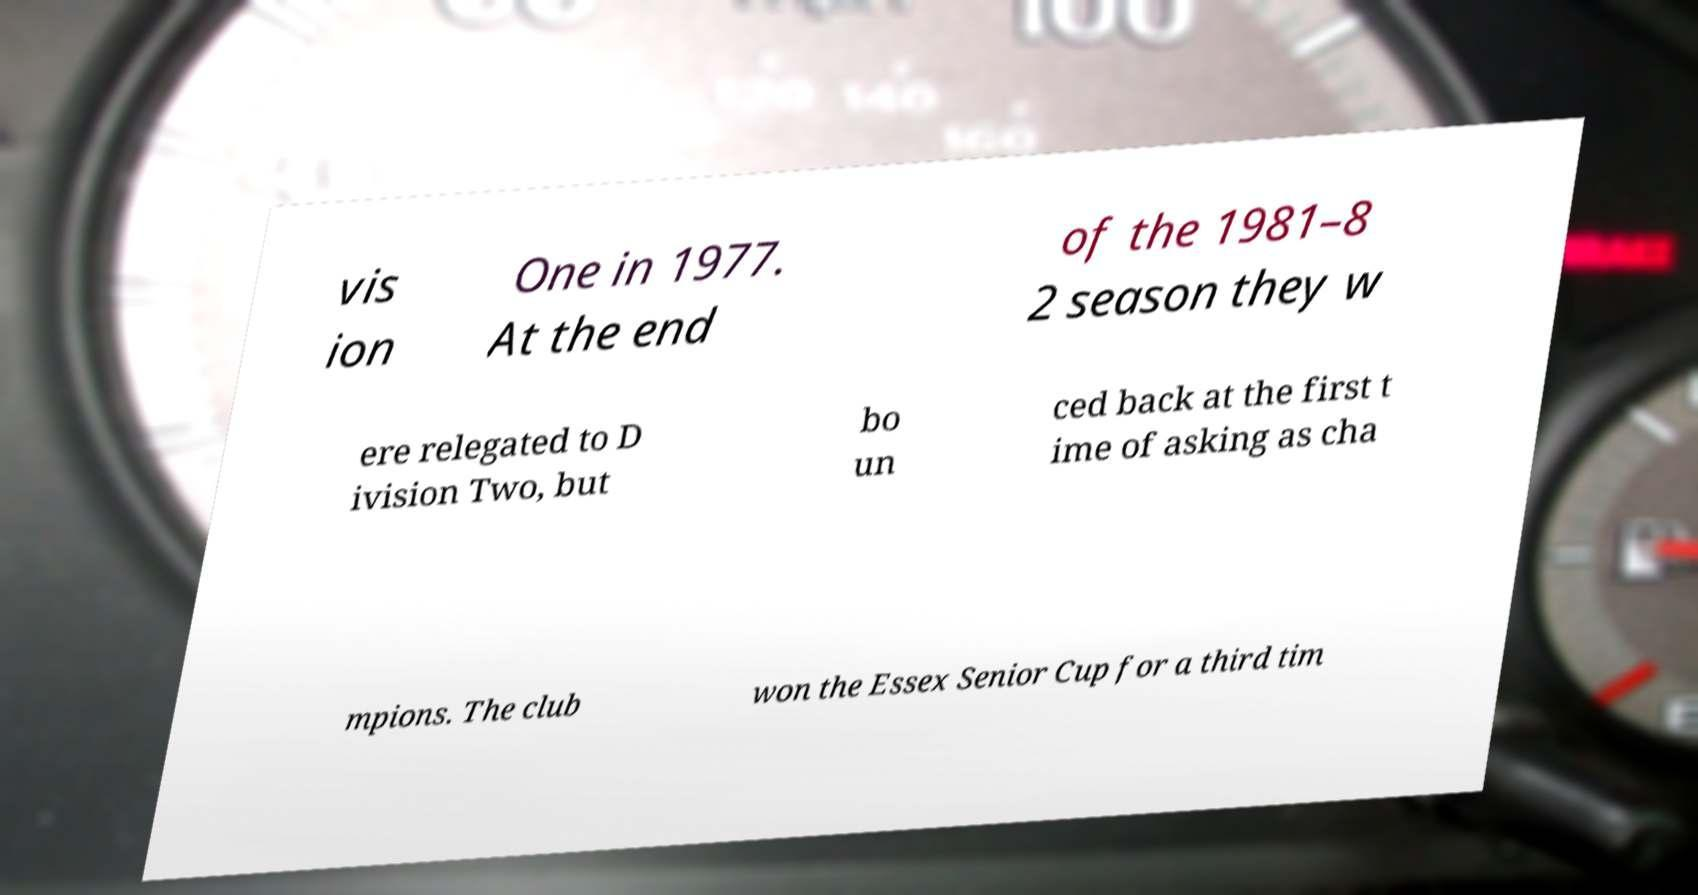Please identify and transcribe the text found in this image. vis ion One in 1977. At the end of the 1981–8 2 season they w ere relegated to D ivision Two, but bo un ced back at the first t ime of asking as cha mpions. The club won the Essex Senior Cup for a third tim 